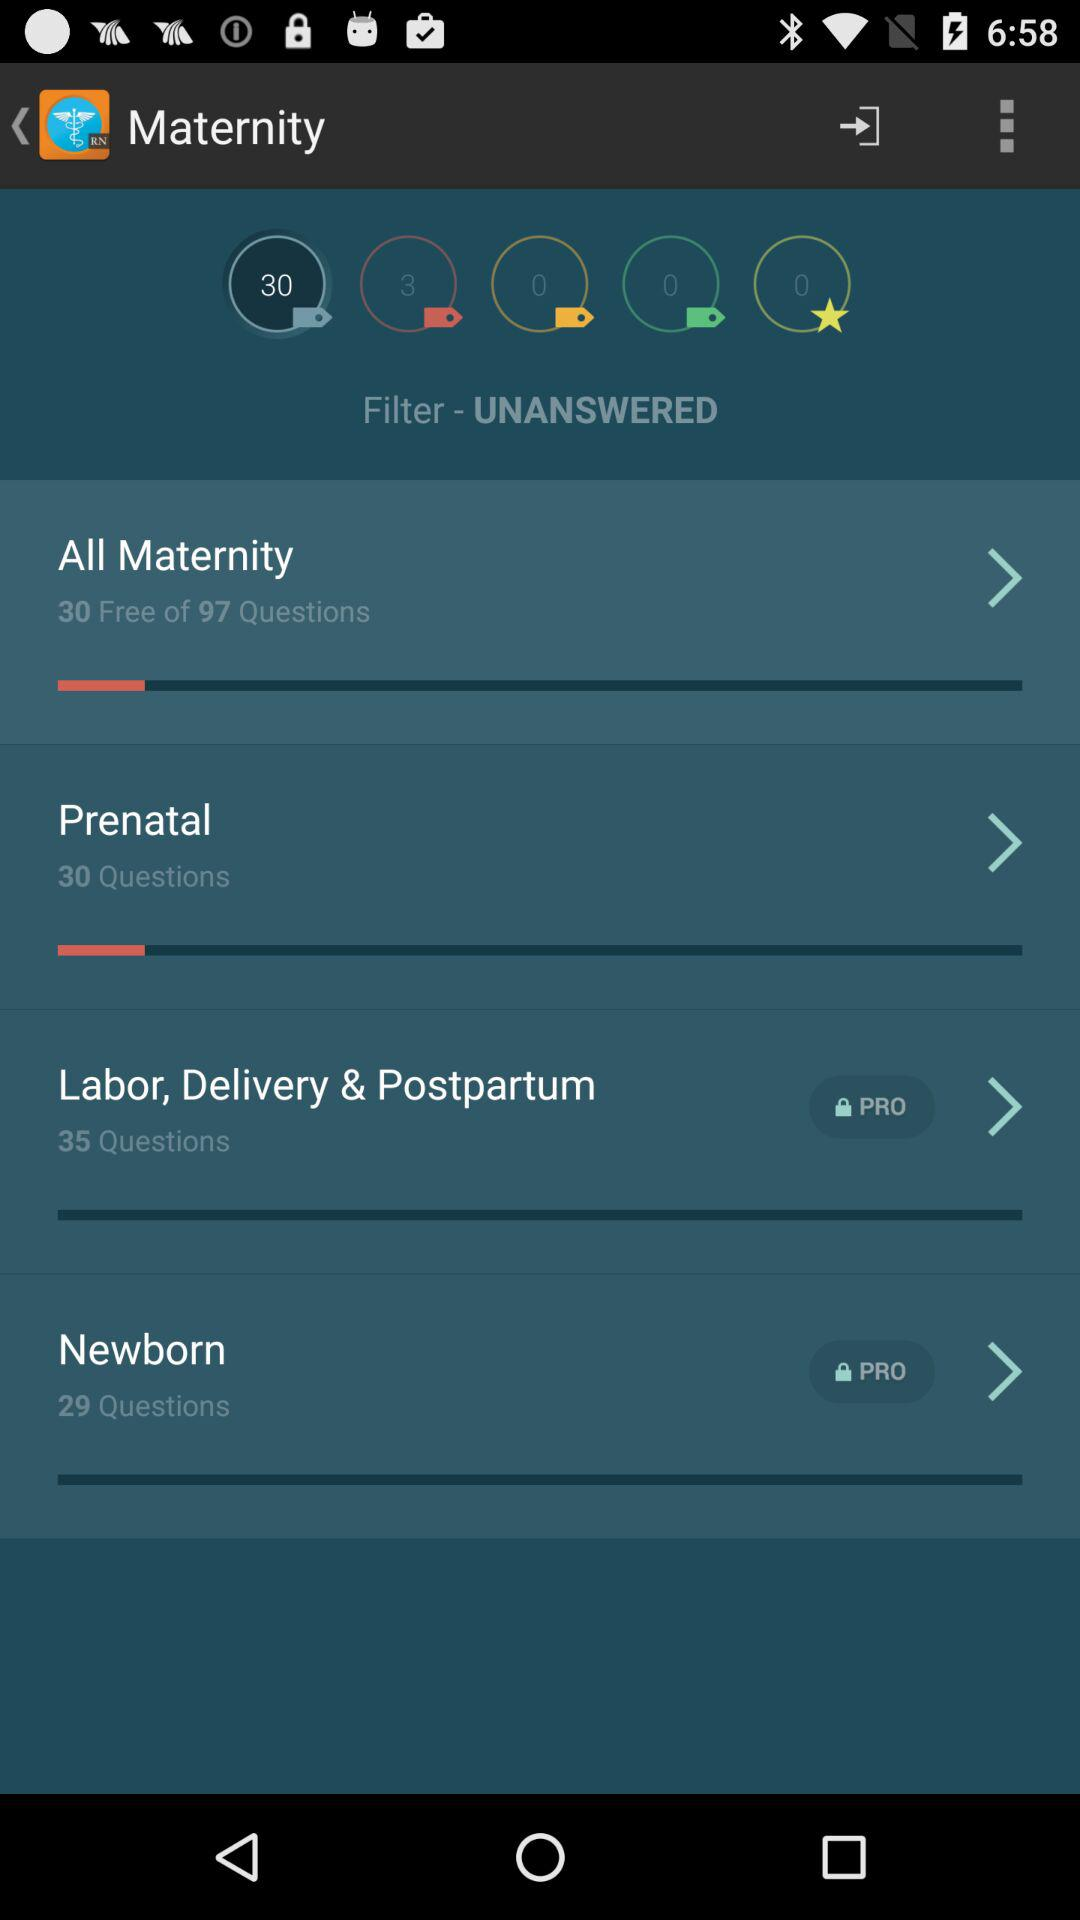What is the filter setting? The filter setting is "UNANSWERED". 